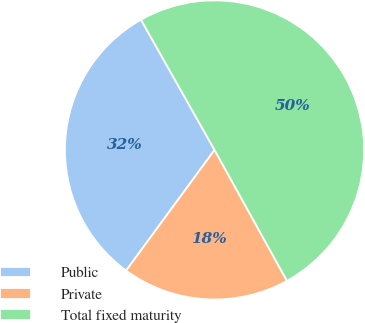Convert chart. <chart><loc_0><loc_0><loc_500><loc_500><pie_chart><fcel>Public<fcel>Private<fcel>Total fixed maturity<nl><fcel>31.75%<fcel>18.11%<fcel>50.14%<nl></chart> 